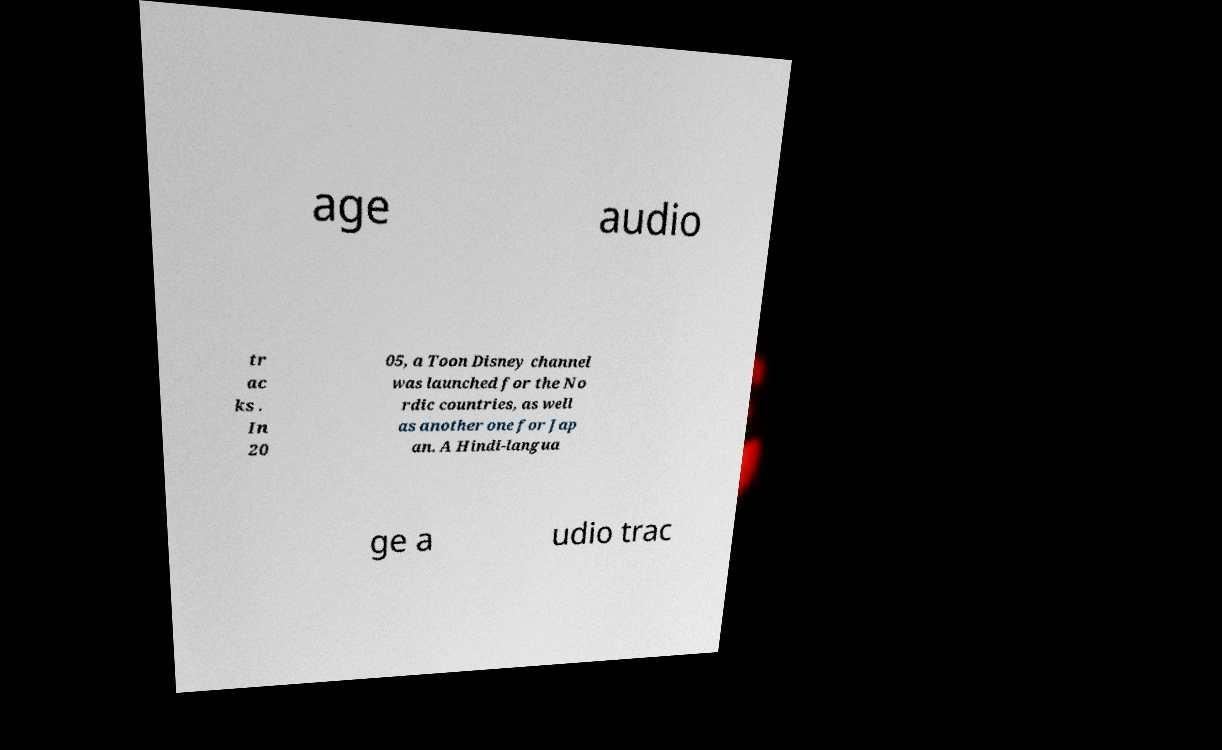Please identify and transcribe the text found in this image. age audio tr ac ks . In 20 05, a Toon Disney channel was launched for the No rdic countries, as well as another one for Jap an. A Hindi-langua ge a udio trac 